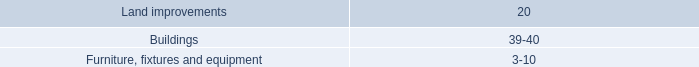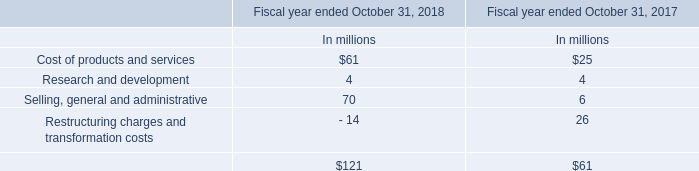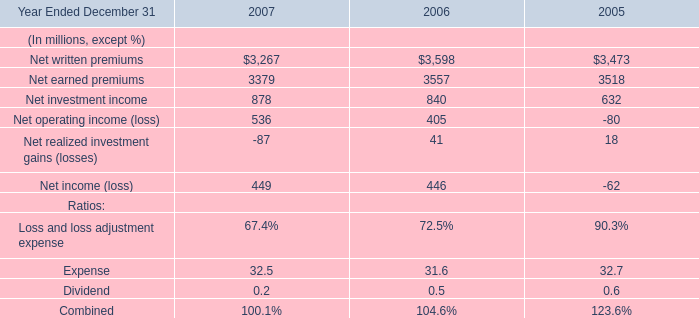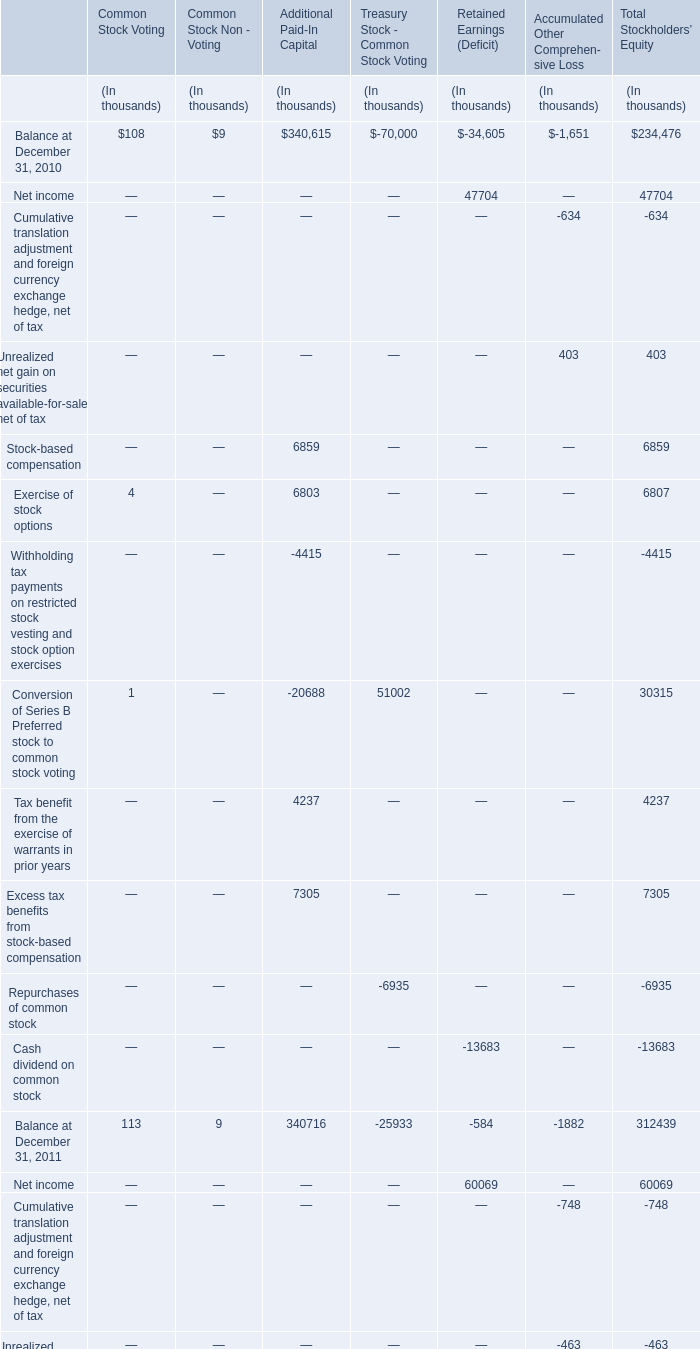what was the percentage change in the excess of current cost over lifo cost from 2008 to 2009 . 
Computations: (50.0 - 6.1)
Answer: 43.9. 